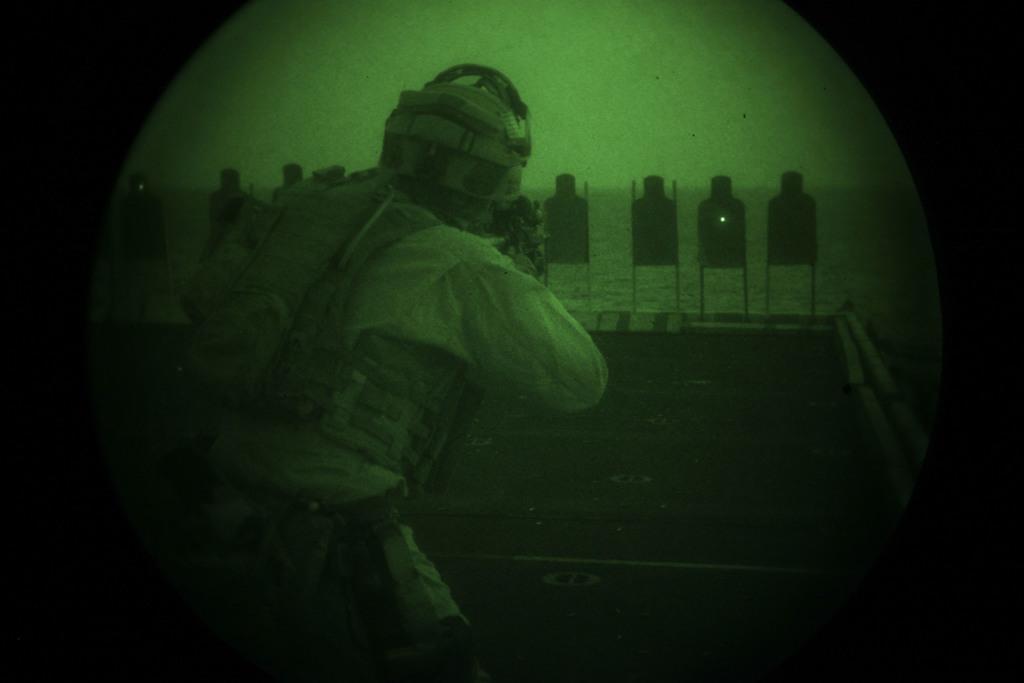How would you summarize this image in a sentence or two? In the foreground of the picture I can see a person and looks like he is holding a weapon. I can see a helmet on his head and he is carrying a bag on his back. In the background, I can see the target boards and the ocean. 